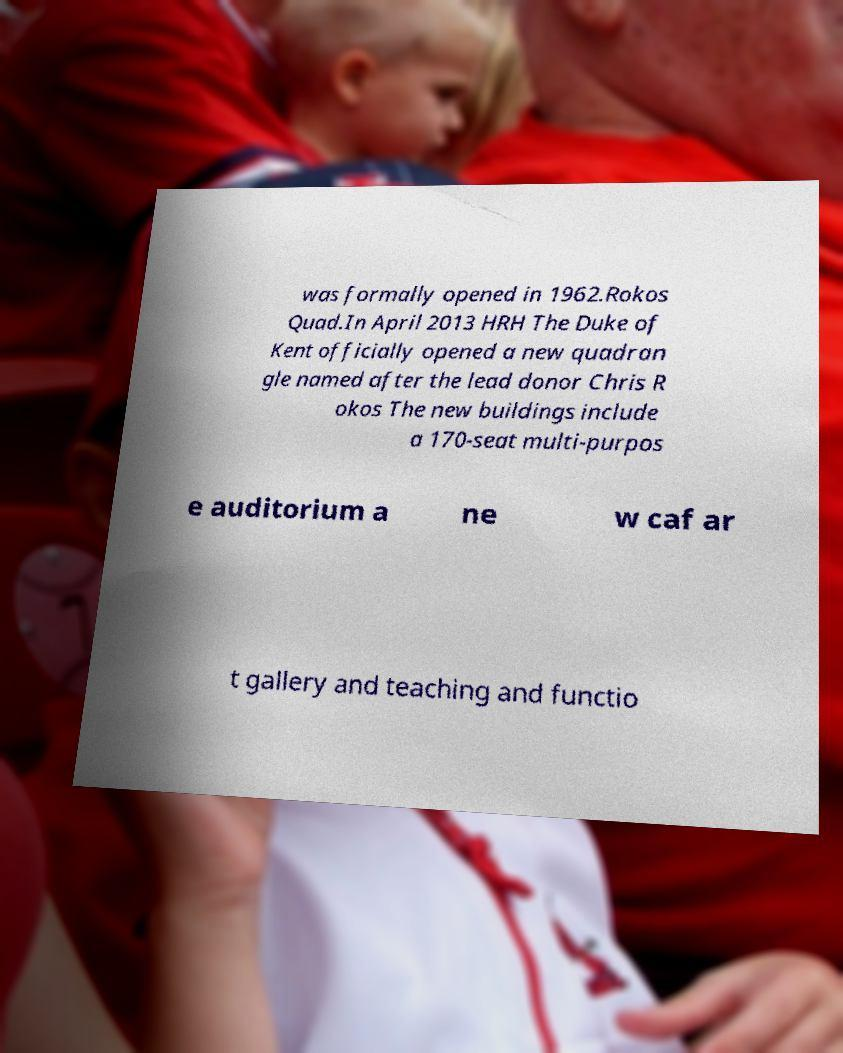Please read and relay the text visible in this image. What does it say? was formally opened in 1962.Rokos Quad.In April 2013 HRH The Duke of Kent officially opened a new quadran gle named after the lead donor Chris R okos The new buildings include a 170-seat multi-purpos e auditorium a ne w caf ar t gallery and teaching and functio 